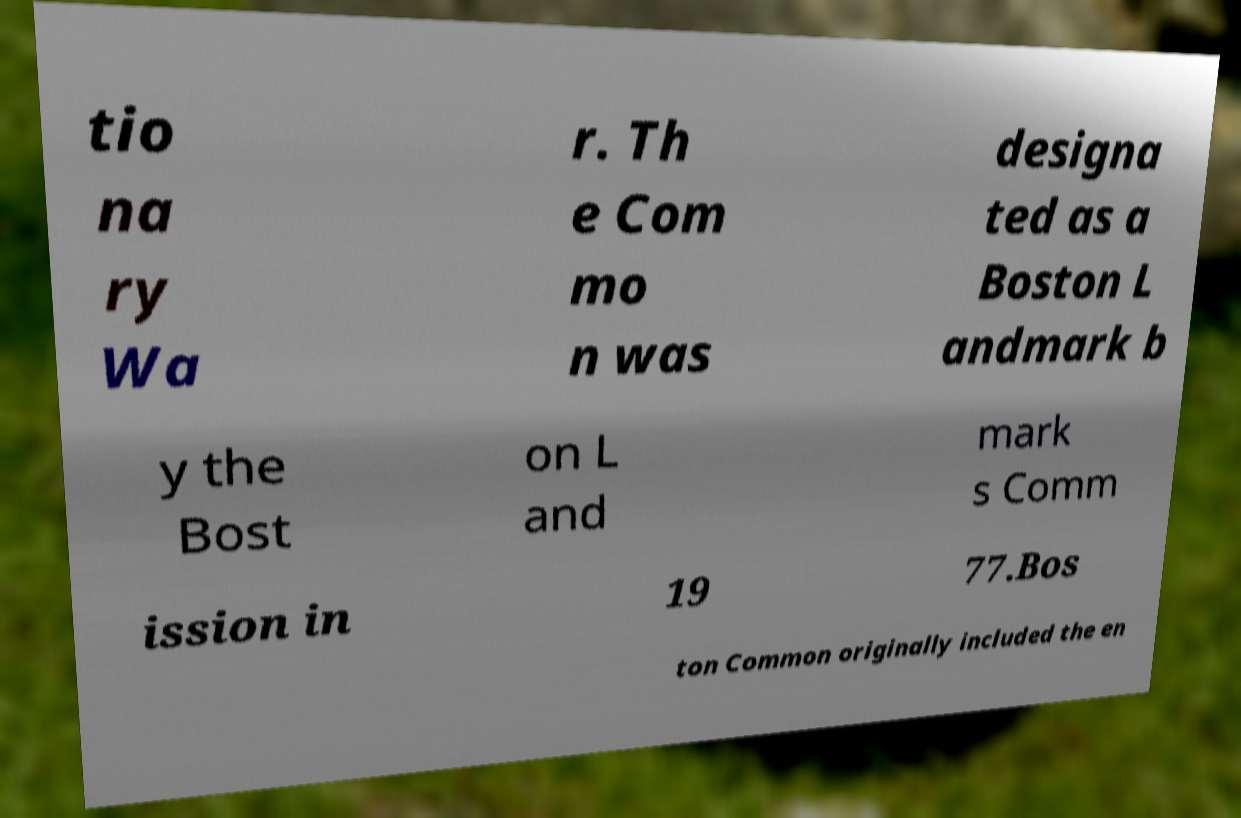Please identify and transcribe the text found in this image. tio na ry Wa r. Th e Com mo n was designa ted as a Boston L andmark b y the Bost on L and mark s Comm ission in 19 77.Bos ton Common originally included the en 